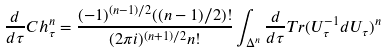Convert formula to latex. <formula><loc_0><loc_0><loc_500><loc_500>\frac { d } { d \tau } C h ^ { n } _ { \tau } = \frac { ( - 1 ) ^ { ( n - 1 ) / 2 } ( ( n - 1 ) / 2 ) ! } { ( 2 \pi i ) ^ { ( n + 1 ) / 2 } n ! } \int _ { \Delta ^ { n } } \frac { d } { d \tau } T r ( U _ { \tau } ^ { - 1 } d U _ { \tau } ) ^ { n }</formula> 